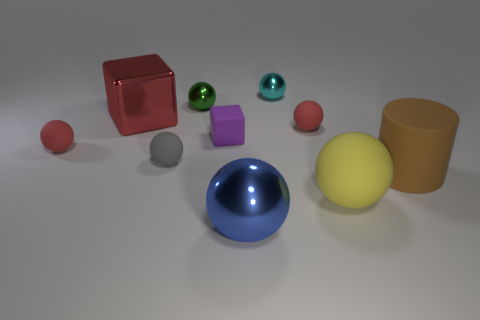Subtract all brown cubes. How many red balls are left? 2 Subtract all large shiny balls. How many balls are left? 6 Subtract all yellow balls. How many balls are left? 6 Subtract 1 balls. How many balls are left? 6 Subtract all cylinders. How many objects are left? 9 Subtract all cyan spheres. Subtract all purple blocks. How many spheres are left? 6 Add 7 tiny red balls. How many tiny red balls are left? 9 Add 7 big blue metal things. How many big blue metal things exist? 8 Subtract 0 green cylinders. How many objects are left? 10 Subtract all green cubes. Subtract all large cylinders. How many objects are left? 9 